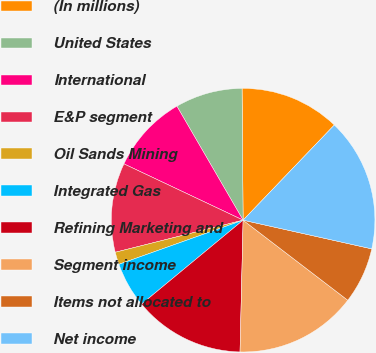Convert chart to OTSL. <chart><loc_0><loc_0><loc_500><loc_500><pie_chart><fcel>(In millions)<fcel>United States<fcel>International<fcel>E&P segment<fcel>Oil Sands Mining<fcel>Integrated Gas<fcel>Refining Marketing and<fcel>Segment income<fcel>Items not allocated to<fcel>Net income<nl><fcel>12.29%<fcel>8.25%<fcel>9.6%<fcel>10.94%<fcel>1.52%<fcel>5.56%<fcel>13.63%<fcel>14.98%<fcel>6.9%<fcel>16.33%<nl></chart> 